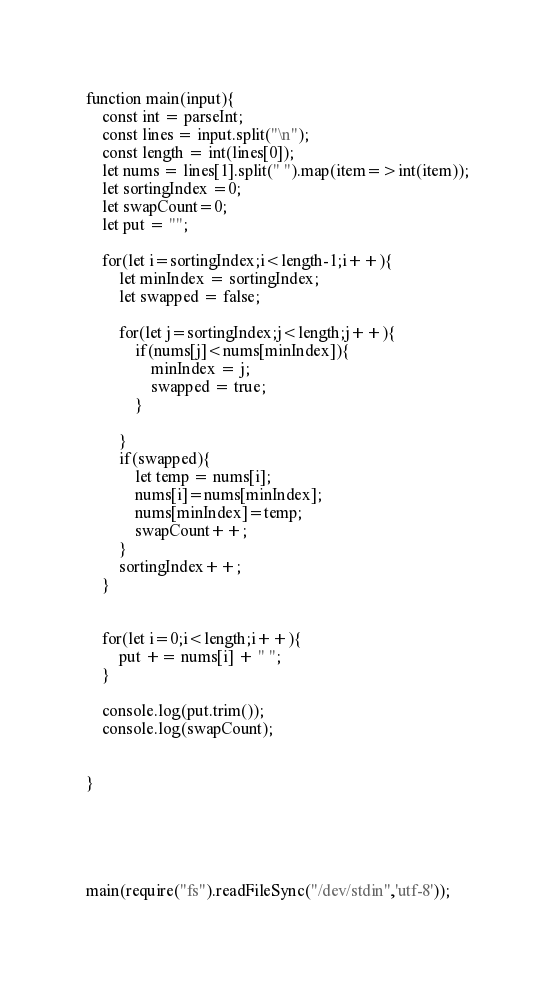Convert code to text. <code><loc_0><loc_0><loc_500><loc_500><_JavaScript_>function main(input){
    const int = parseInt;
    const lines = input.split("\n");
    const length = int(lines[0]);
    let nums = lines[1].split(" ").map(item=>int(item));
    let sortingIndex =0;
    let swapCount=0;
    let put = "";

    for(let i=sortingIndex;i<length-1;i++){
        let minIndex = sortingIndex;
        let swapped = false;

        for(let j=sortingIndex;j<length;j++){
            if(nums[j]<nums[minIndex]){
                minIndex = j;
                swapped = true;
            }
            
        }
        if(swapped){
            let temp = nums[i];
            nums[i]=nums[minIndex];
            nums[minIndex]=temp;
            swapCount++;
        }
        sortingIndex++;
    }
    
    
    for(let i=0;i<length;i++){
        put += nums[i] + " ";
    }
    
    console.log(put.trim());
    console.log(swapCount);
    
    
}





main(require("fs").readFileSync("/dev/stdin",'utf-8'));
</code> 